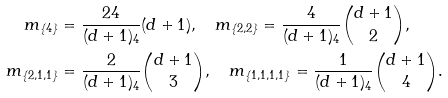Convert formula to latex. <formula><loc_0><loc_0><loc_500><loc_500>m _ { \{ 4 \} } & = \frac { 2 4 } { ( d + 1 ) _ { 4 } } ( d + 1 ) , \quad m _ { \{ 2 , 2 \} } = \frac { 4 } { ( d + 1 ) _ { 4 } } \binom { d + 1 } { 2 } , \\ m _ { \{ 2 , 1 , 1 \} } & = \frac { 2 } { ( d + 1 ) _ { 4 } } \binom { d + 1 } { 3 } , \quad m _ { \{ 1 , 1 , 1 , 1 \} } = \frac { 1 } { ( d + 1 ) _ { 4 } } \binom { d + 1 } { 4 } .</formula> 